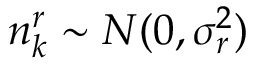<formula> <loc_0><loc_0><loc_500><loc_500>n _ { k } ^ { r } \sim N ( 0 , \sigma _ { r } ^ { 2 } )</formula> 